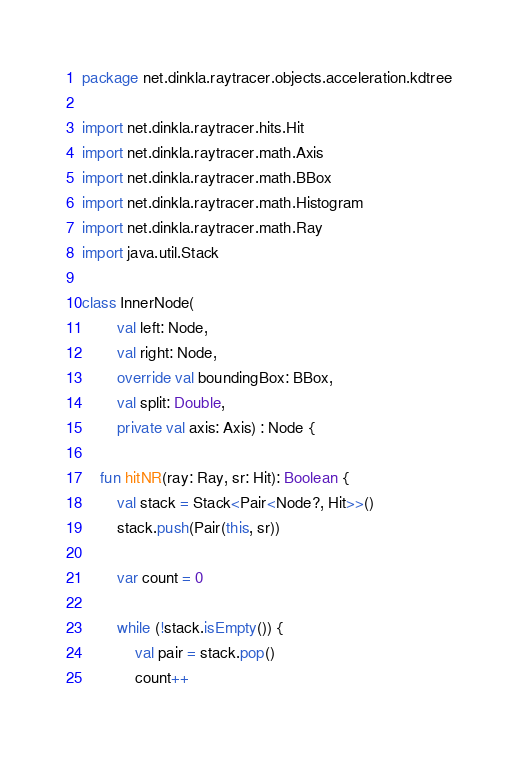<code> <loc_0><loc_0><loc_500><loc_500><_Kotlin_>package net.dinkla.raytracer.objects.acceleration.kdtree

import net.dinkla.raytracer.hits.Hit
import net.dinkla.raytracer.math.Axis
import net.dinkla.raytracer.math.BBox
import net.dinkla.raytracer.math.Histogram
import net.dinkla.raytracer.math.Ray
import java.util.Stack

class InnerNode(
        val left: Node,
        val right: Node,
        override val boundingBox: BBox,
        val split: Double,
        private val axis: Axis) : Node {

    fun hitNR(ray: Ray, sr: Hit): Boolean {
        val stack = Stack<Pair<Node?, Hit>>()
        stack.push(Pair(this, sr))

        var count = 0

        while (!stack.isEmpty()) {
            val pair = stack.pop()
            count++</code> 